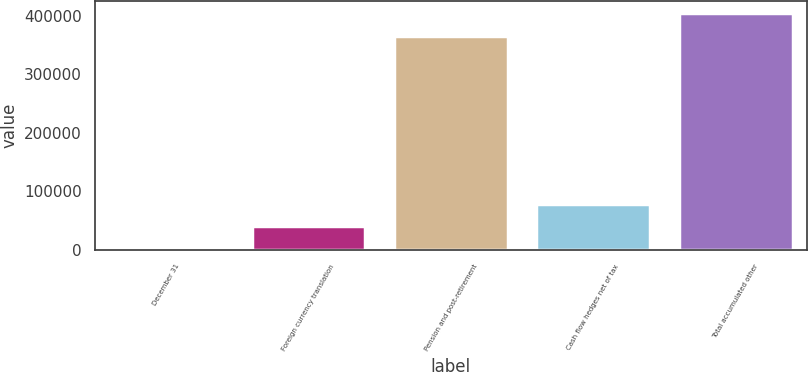<chart> <loc_0><loc_0><loc_500><loc_500><bar_chart><fcel>December 31<fcel>Foreign currency translation<fcel>Pension and post-retirement<fcel>Cash flow hedges net of tax<fcel>Total accumulated other<nl><fcel>2012<fcel>40318.4<fcel>366037<fcel>78624.8<fcel>404343<nl></chart> 